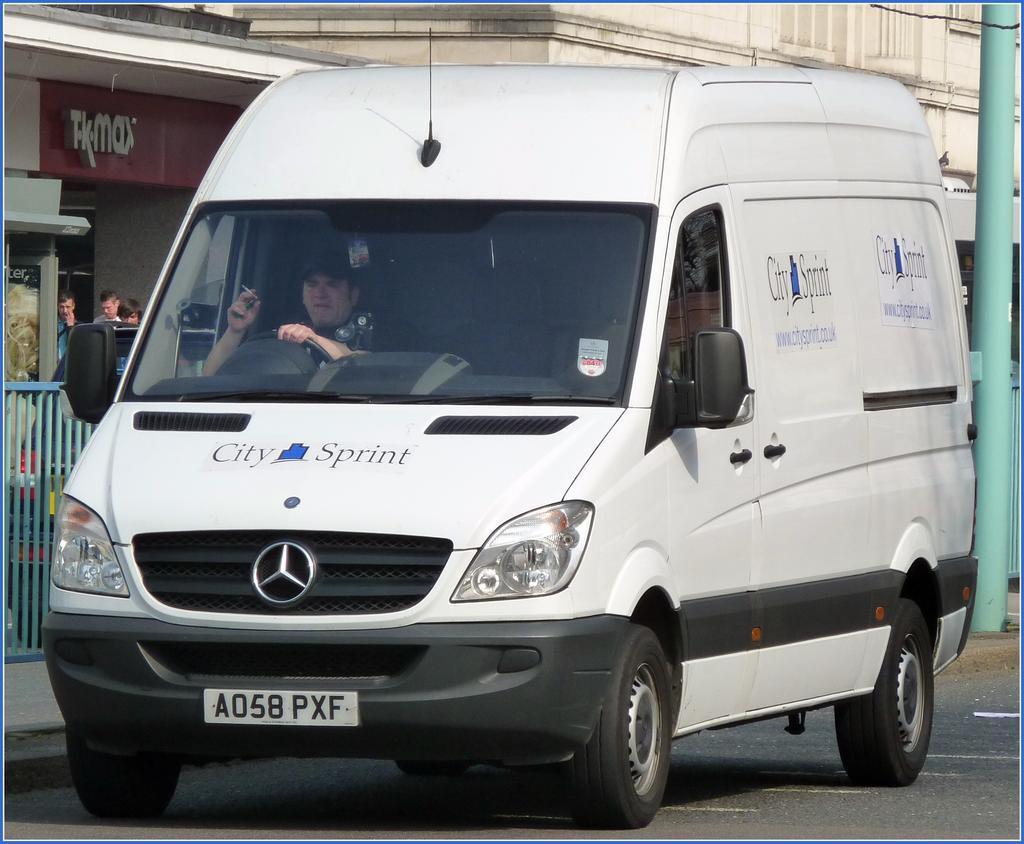Describe this image in one or two sentences. In this picture there is a man who is sitting inside the van and he is holding a cigarette. On the left I can see some people were standing in front of the door and fencing. On the right I can see the pole and building. 